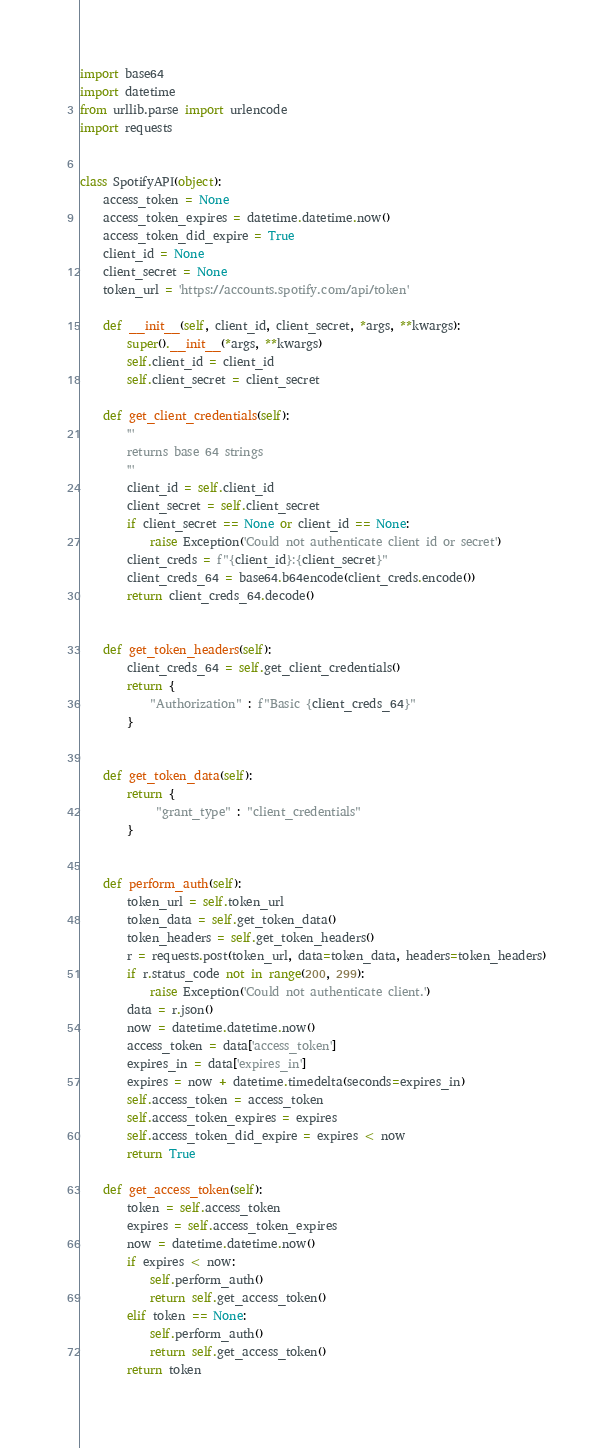Convert code to text. <code><loc_0><loc_0><loc_500><loc_500><_Python_>import base64
import datetime
from urllib.parse import urlencode
import requests


class SpotifyAPI(object):
    access_token = None
    access_token_expires = datetime.datetime.now()
    access_token_did_expire = True
    client_id = None
    client_secret = None
    token_url = 'https://accounts.spotify.com/api/token'

    def __init__(self, client_id, client_secret, *args, **kwargs):
        super().__init__(*args, **kwargs)
        self.client_id = client_id
        self.client_secret = client_secret

    def get_client_credentials(self):
        '''
        returns base 64 strings
        '''
        client_id = self.client_id
        client_secret = self.client_secret
        if client_secret == None or client_id == None:
            raise Exception('Could not authenticate client id or secret')
        client_creds = f"{client_id}:{client_secret}"
        client_creds_64 = base64.b64encode(client_creds.encode())
        return client_creds_64.decode()


    def get_token_headers(self):
        client_creds_64 = self.get_client_credentials()
        return {
            "Authorization" : f"Basic {client_creds_64}"
        }


    def get_token_data(self):
        return {
             "grant_type" : "client_credentials"
        }


    def perform_auth(self):
        token_url = self.token_url
        token_data = self.get_token_data()
        token_headers = self.get_token_headers()
        r = requests.post(token_url, data=token_data, headers=token_headers)
        if r.status_code not in range(200, 299):
            raise Exception('Could not authenticate client.')
        data = r.json()
        now = datetime.datetime.now()
        access_token = data['access_token']
        expires_in = data['expires_in']
        expires = now + datetime.timedelta(seconds=expires_in)
        self.access_token = access_token
        self.access_token_expires = expires
        self.access_token_did_expire = expires < now
        return True

    def get_access_token(self):
        token = self.access_token
        expires = self.access_token_expires
        now = datetime.datetime.now()
        if expires < now:
            self.perform_auth()
            return self.get_access_token()
        elif token == None:
            self.perform_auth()
            return self.get_access_token()
        return token
</code> 